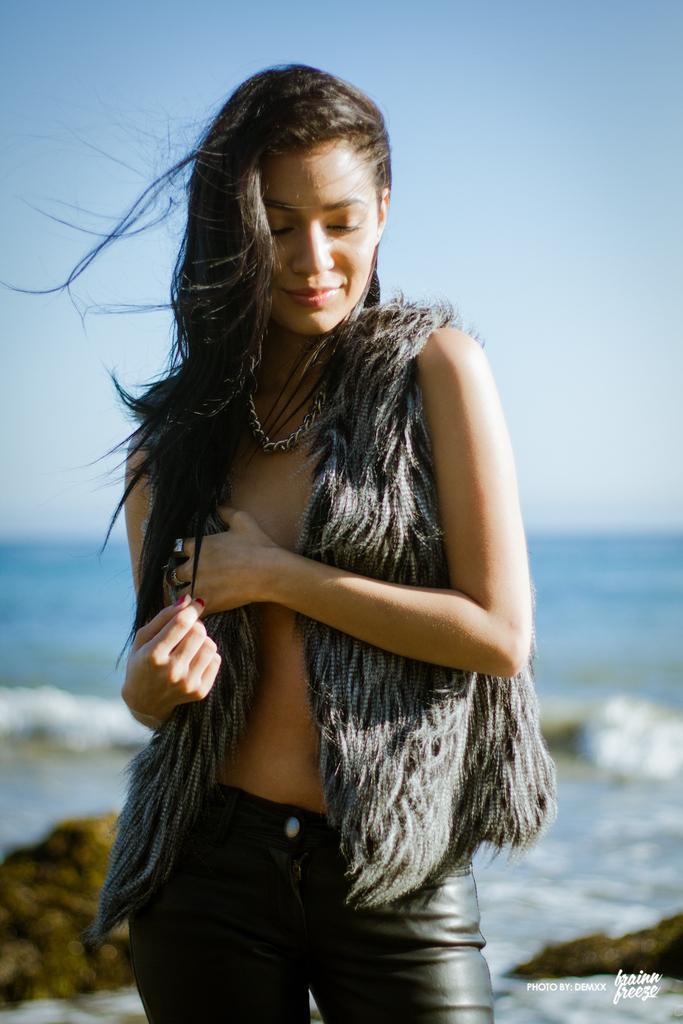Can you describe this image briefly? In this image in front there is a person. Behind her there are rocks. In the background of the image there is water and sky. 